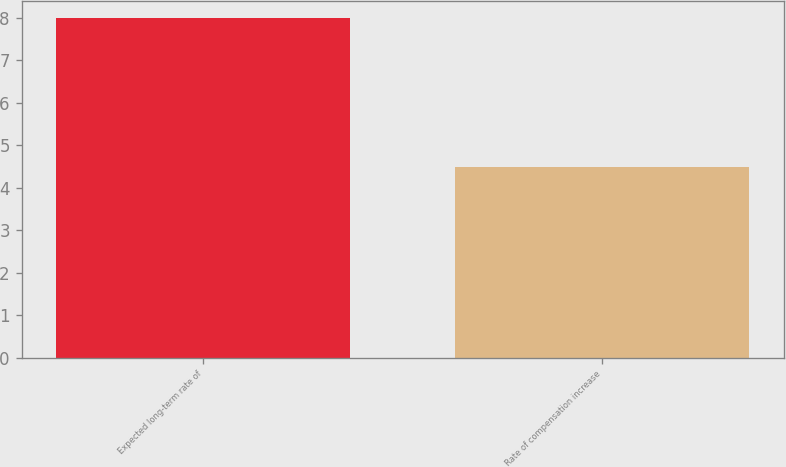Convert chart. <chart><loc_0><loc_0><loc_500><loc_500><bar_chart><fcel>Expected long-term rate of<fcel>Rate of compensation increase<nl><fcel>8<fcel>4.5<nl></chart> 